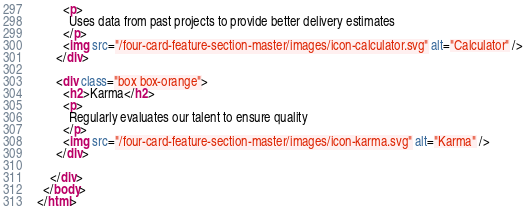Convert code to text. <code><loc_0><loc_0><loc_500><loc_500><_HTML_>        <p>
          Uses data from past projects to provide better delivery estimates
        </p>
        <img src="/four-card-feature-section-master/images/icon-calculator.svg" alt="Calculator" />
      </div>

      <div class="box box-orange">
        <h2>Karma</h2>
        <p>
          Regularly evaluates our talent to ensure quality
        </p>
        <img src="/four-card-feature-section-master/images/icon-karma.svg" alt="Karma" />
      </div>

    </div>
  </body>
</html>
</code> 